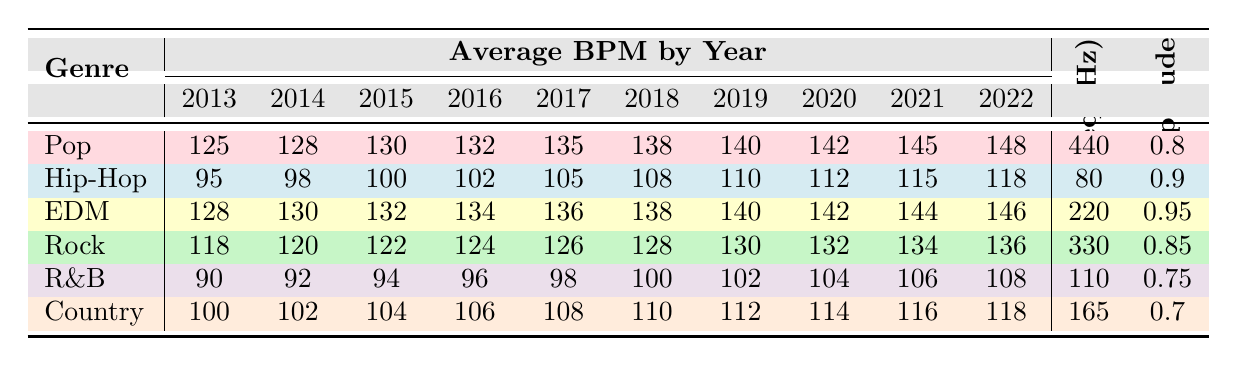What is the average BPM of the EDM genre in 2021? From the table, the BPM for EDM in 2021 is 144, which is directly listed under that year.
Answer: 144 Which genre had the highest BPM in 2022? By comparing the BPM values for each genre in 2022, Pop has the highest BPM at 148.
Answer: Pop What is the dominant frequency for the Rock genre? The table provides the dominant frequency for Rock, which is listed as 330 Hz.
Answer: 330 Hz How much did the average BPM of Country music increase from 2013 to 2022? In 2013, the BPM for Country was 100, and in 2022 it is 118. The increase is calculated as 118 - 100 = 18.
Answer: 18 True or False: The average amplitude for R&B is higher than that of Country. The average amplitude for R&B is 0.75, while Country’s average amplitude is 0.7, so the statement is true.
Answer: True What is the average BPM for the Pop genre over the years 2013 to 2022? We sum the BPM values for Pop from 2013 to 2022: (125 + 128 + 130 + 132 + 135 + 138 + 140 + 142 + 145 + 148) = 1,430. There are 10 years, so the average is 1,430 / 10 = 143.
Answer: 143 Which genre experienced the least growth in BPM from 2013 to 2022? Calculate the growth for each genre: Pop (148-125=23), Hip-Hop (118-95=23), EDM (146-128=18), Rock (136-118=18), R&B (108-90=18), Country (118-100=18). EDM, Rock, R&B, and Country all had the minimum growth of 18.
Answer: EDM, Rock, R&B, Country What were the average amplitudes of Hip-Hop and R&B combined? The average amplitudes are Hip-Hop (0.9) and R&B (0.75). To find the combined average, add them (0.9 + 0.75 = 1.65) and divide by 2, resulting in 1.65 / 2 = 0.825.
Answer: 0.825 How many genres have a dominant frequency below 200 Hz? The table shows the dominant frequencies: Pop (440), Hip-Hop (80), EDM (220), Rock (330), R&B (110), Country (165). The frequencies below 200 Hz are Hip-Hop (80), R&B (110), and Country (165), totaling 3 genres.
Answer: 3 Which two genres have the same average amplitude, and what is that amplitude? R&B (0.75) and Country (0.7) do not have the same amplitude, but looking at the table reveals that Pop (0.8) and Rock (0.85) also differ. No genres have the same average amplitude since all are different.
Answer: N/A (No two genres share the same amplitude) 